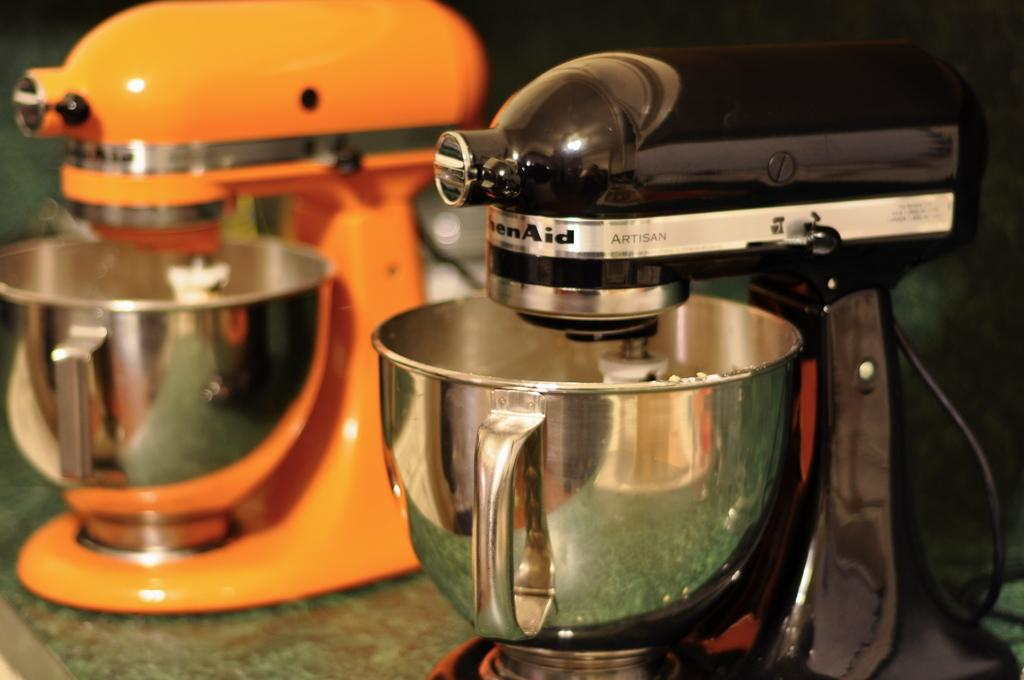Provide a one-sentence caption for the provided image. One black and one orange Kitchen Aid stand mixers. 